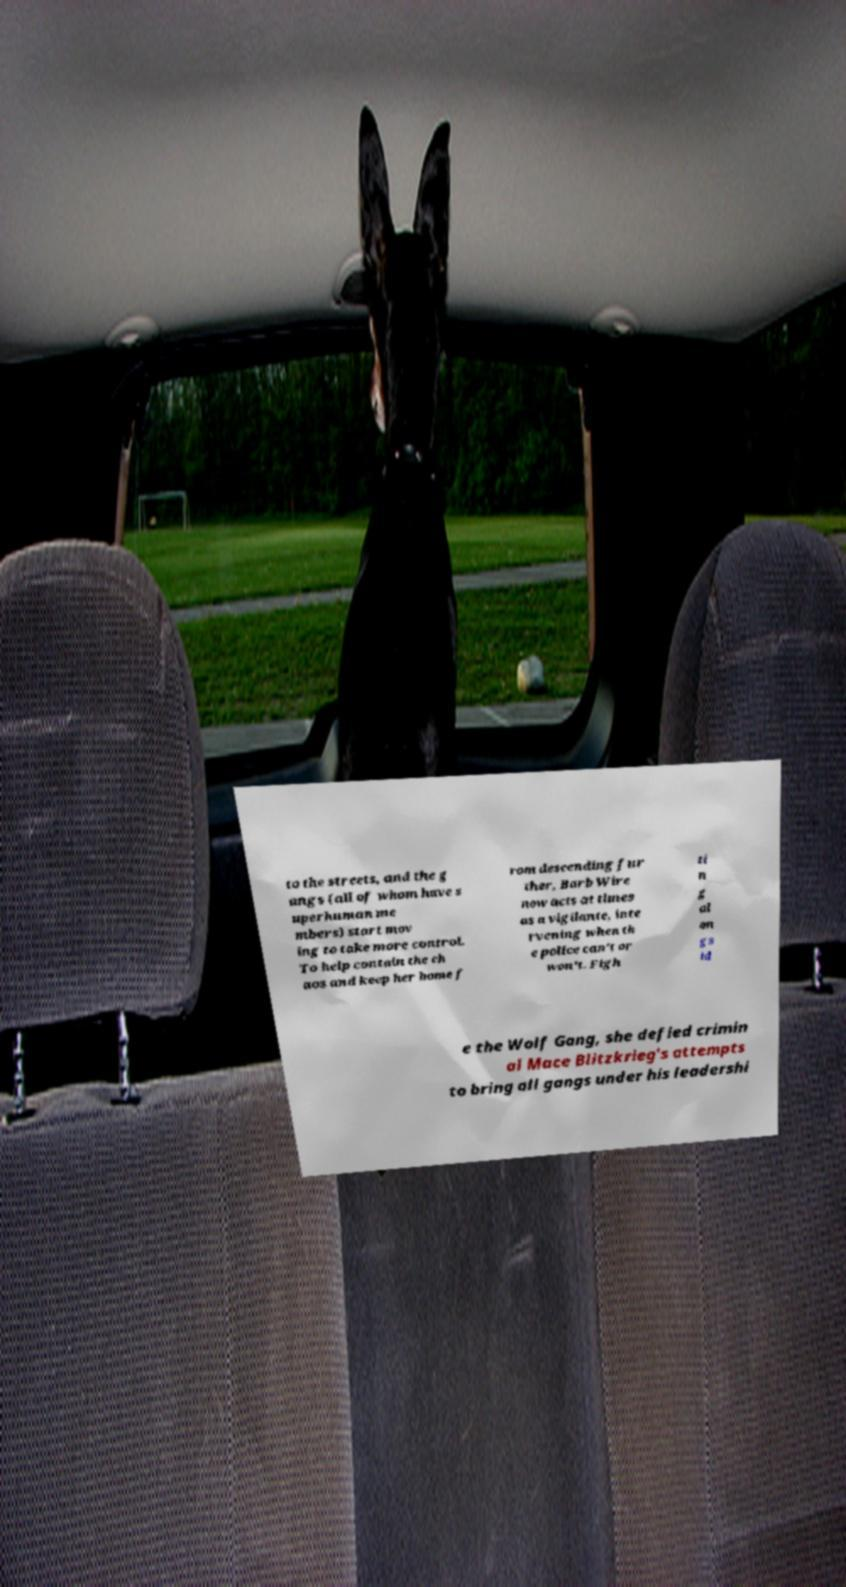What messages or text are displayed in this image? I need them in a readable, typed format. to the streets, and the g angs (all of whom have s uperhuman me mbers) start mov ing to take more control. To help contain the ch aos and keep her home f rom descending fur ther, Barb Wire now acts at times as a vigilante, inte rvening when th e police can't or won't. Figh ti n g al on gs id e the Wolf Gang, she defied crimin al Mace Blitzkrieg's attempts to bring all gangs under his leadershi 